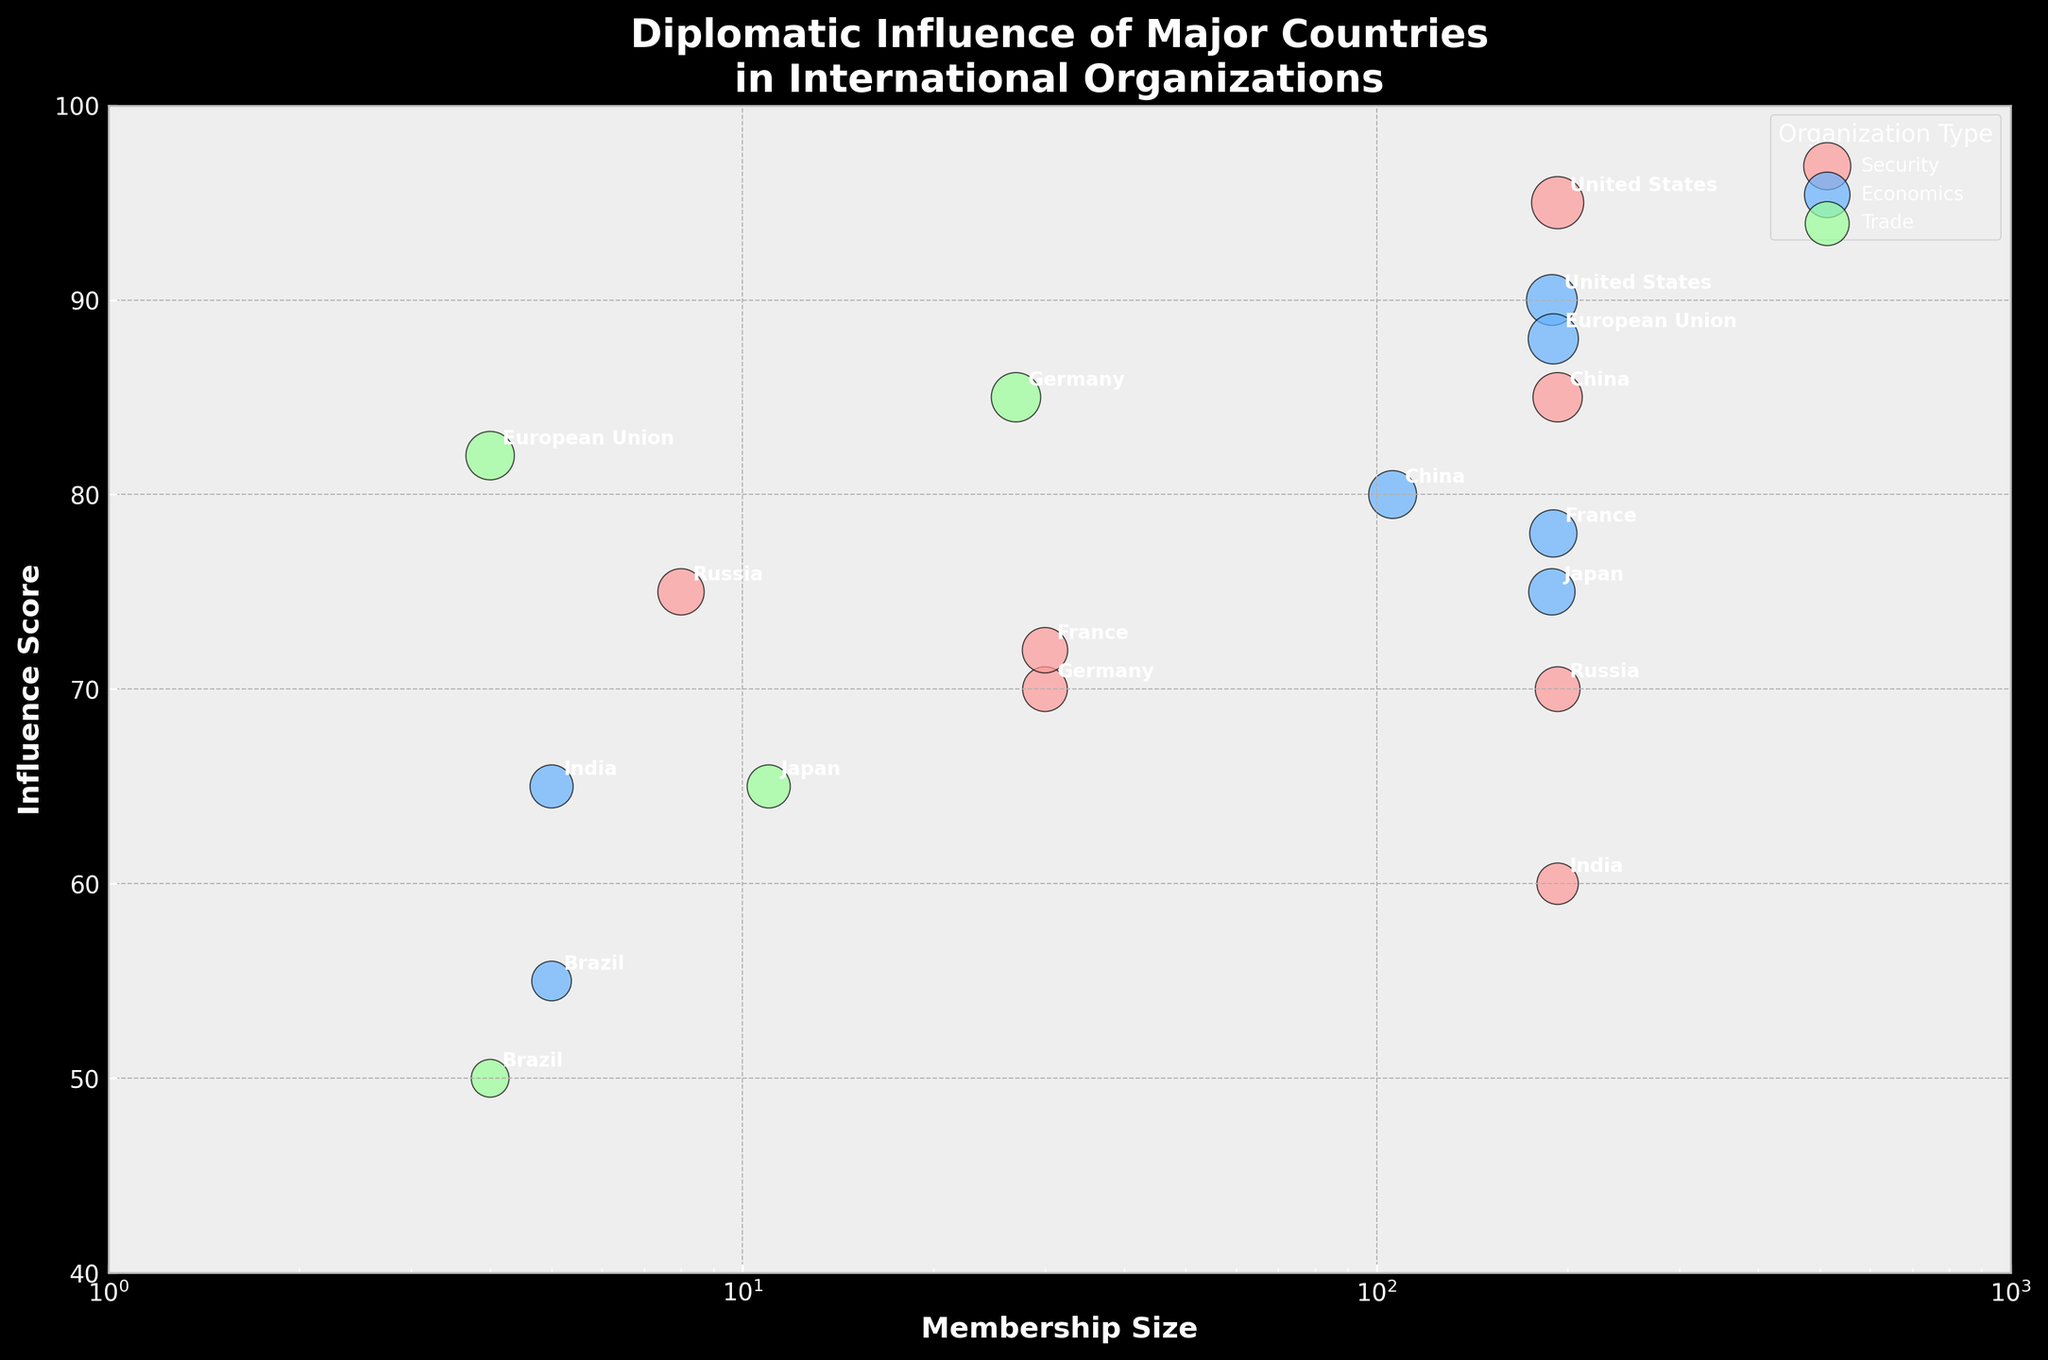what is the title of the figure? The title of the figure is displayed at the top of the plot. It is "Diplomatic Influence of Major Countries in International Organizations".
Answer: Diplomatic Influence of Major Countries in International Organizations what do the bubble sizes represent? The size of each bubble represents the Influence Score of the corresponding country in a particular international organization.
Answer: Influence Score which country has the highest influence score in the United Nations Security Council? To find this, look for the country label with the highest y-coordinate within the United Nations Security Council bubbles. The United States has the highest Influence Score in the United Nations Security Council.
Answer: United States What is the range of Influence Scores displayed in the figure? The y-axis represents the Influence Score, ranging from 40 to 100 as indicated by the scale on the side.
Answer: 40 to 100 Which organization type has the most frequent presence on the chart? To determine this, observe the legend and count the occurrences of security, economics, and trade bubbles. The 'Economics' organization type appears most frequently.
Answer: Economics Compare the influence scores of Germany and France in NATO. Which country has a higher score? To compare, find the bubbles for Germany and France within NATO and compare their y-coordinates. France has a score of 72, while Germany has a score of 70.
Answer: France What's the median Influence Score for the Economics organization type? To find the median, first list the Influence Scores for Economics organizations: 90, 88, 80, 75, 65, 78, 55. Ordering them gives 55, 65, 75, 78, 80, 88, 90. The median is the middle value, which is 78.
Answer: 78 Which country is represented in trade organizations with the highest Influence Score, and what is that score? Look for the highest bubble among trade organizations and check the country label. The highest Trade Influence Score is for Germany in the European Union with a score of 85.
Answer: Germany, 85 In the Economics organizations, which country has the lowest Influence Score and what is the score? Find the lowest bubble in the Economics organizations. Brazil has the lowest score in BRICS with a score of 55.
Answer: Brazil, 55 What is the difference in Influence Scores between the United States and Russia in the United Nations Security Council? To find the difference, subtract Russia's score from the United States' score in the United Nations Security Council. United States: 95, Russia: 70. The difference is 95 - 70 = 25.
Answer: 25 